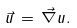<formula> <loc_0><loc_0><loc_500><loc_500>\vec { u } \, = \, \vec { \nabla } u .</formula> 